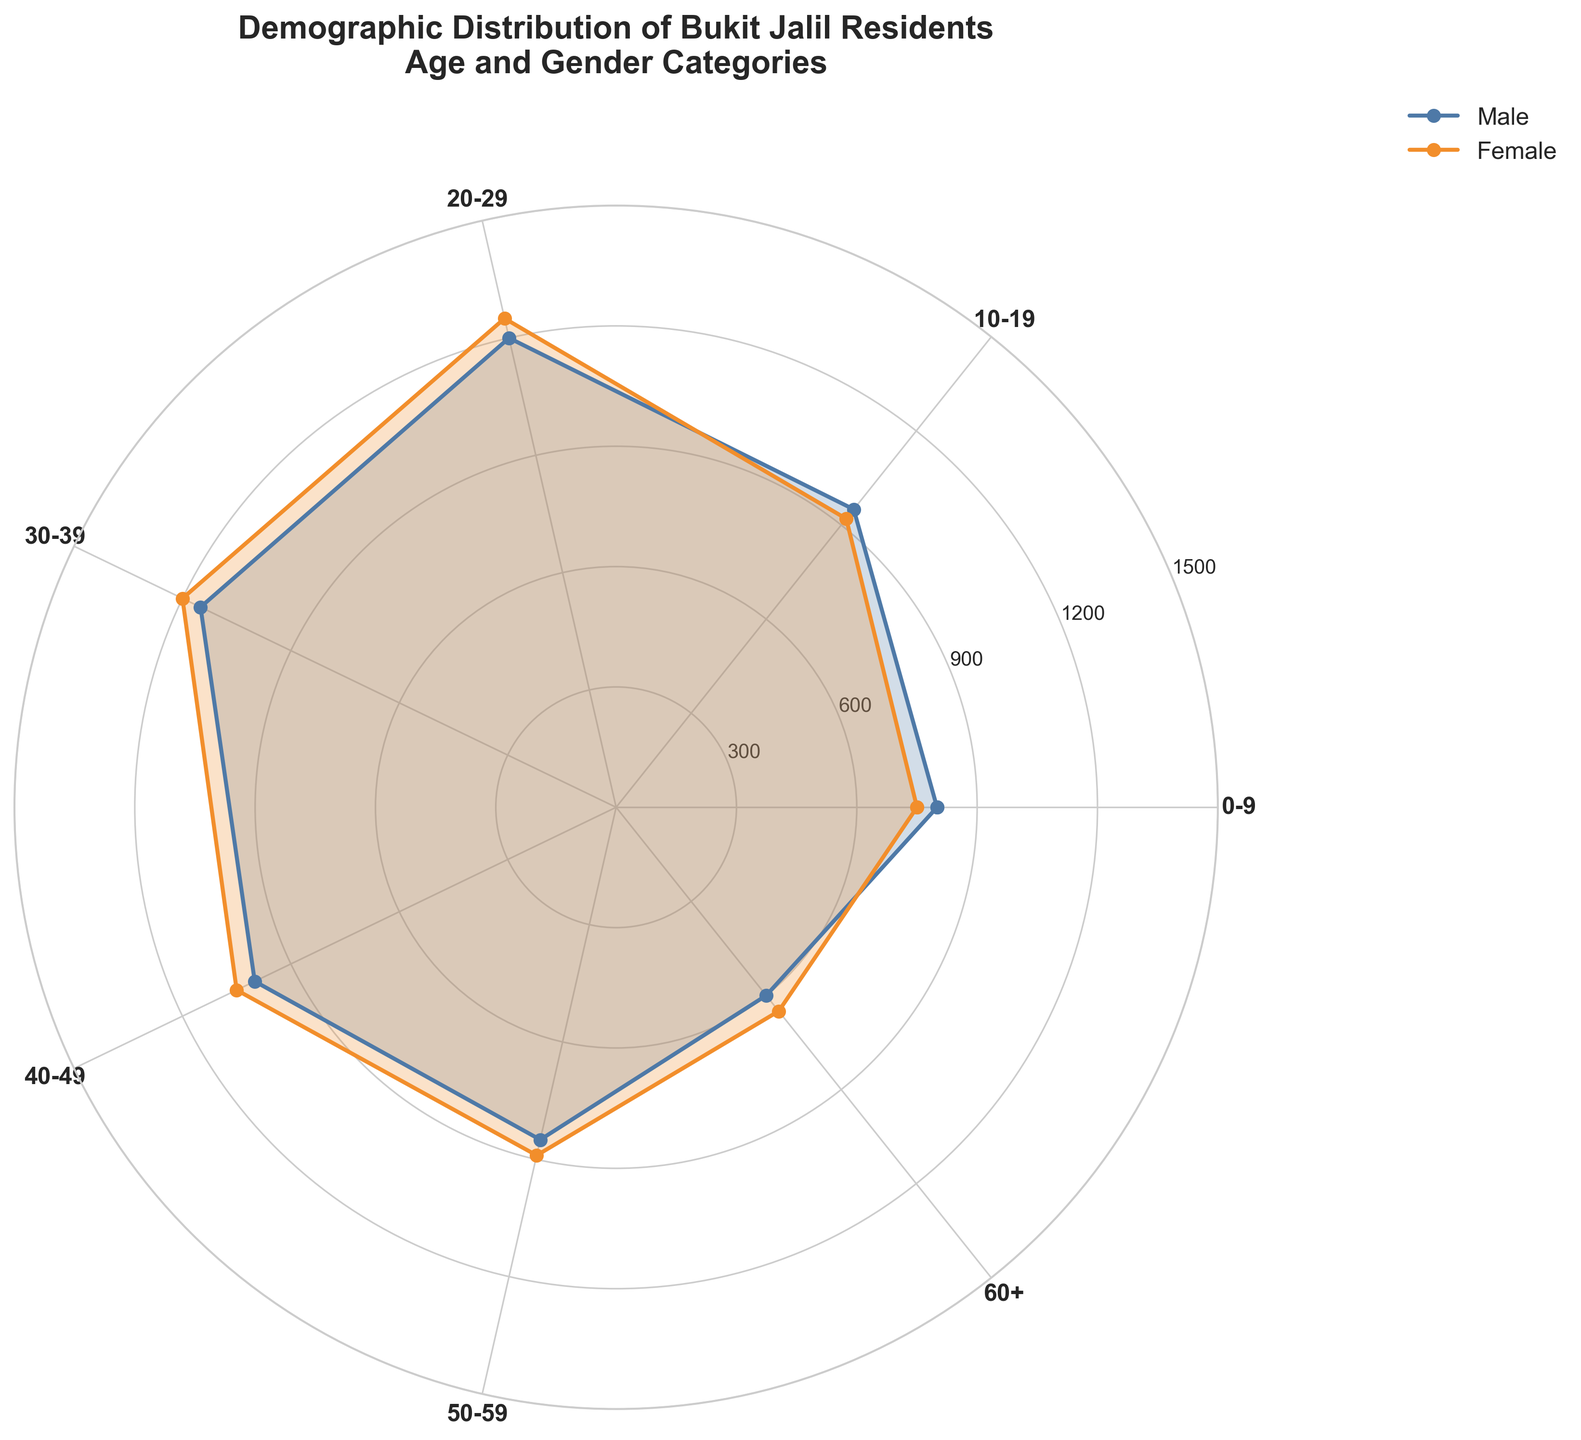What is the title of the plot? The title is displayed at the top of the figure. It provides information about the theme of the chart.
Answer: Demographic Distribution of Bukit Jalil Residents - Age and Gender Categories Which age group has the highest male population? Look at the male data points (displayed using a blue line) and identify the longest bar. The 20-29 age group has the longest bar for males.
Answer: 20-29 How does the female population in the 30-39 age group compare to the 30-39 male population? Compare the length of the orange bar (female) and blue bar (male) at the 30-39 category. The female bar is slightly longer.
Answer: Female population is slightly larger What is the range of population values on the radial scale? The radial scale (circular y-axis) shows values starting from 0 at the center to 1500 at the outermost ring. Observe the values marked on this scale.
Answer: 0 to 1500 Between which age groups does the male population decrease? Examine the length of the blue bars (male data) as they move from one age group to the next. Notice decreases from 20-29 to 30-39, and again from 40-49 to 50-59, and further to 60+.
Answer: 20-29 to 30-39, 40-49 to 50-59, 50-59 to 60+ Which gender appears to have a greater population across most age groups? Compare the areas filled by the blue (male) and orange (female) colors for each age category. Female areas are generally larger or equal.
Answer: Female What is the total population for all age groups combined? Sum all the values for both Male and Female data points across all age groups (800 + 750 + 950 + 920 + 1200 + 1250 + 1150 + 1200 + 1000 + 1050 + 850 + 890 + 600 + 650).
Answer: 13260 What is the difference in population size between the 40-49 male group and the 50-59 female group? Subtract the population size of 50-59 females from the 40-49 males. 1000 (40-49 males) - 890 (50-59 females).
Answer: 110 Which age group has the smallest difference between male and female populations? Calculate the absolute differences between male and female populations in each age group, then identify the smallest difference. The 10-19 age group has the smallest difference (950-920 = 30).
Answer: 10-19 